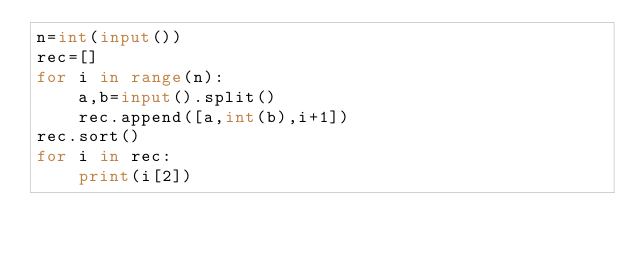<code> <loc_0><loc_0><loc_500><loc_500><_Python_>n=int(input())
rec=[]
for i in range(n):
    a,b=input().split()
    rec.append([a,int(b),i+1])
rec.sort()
for i in rec:
    print(i[2])</code> 